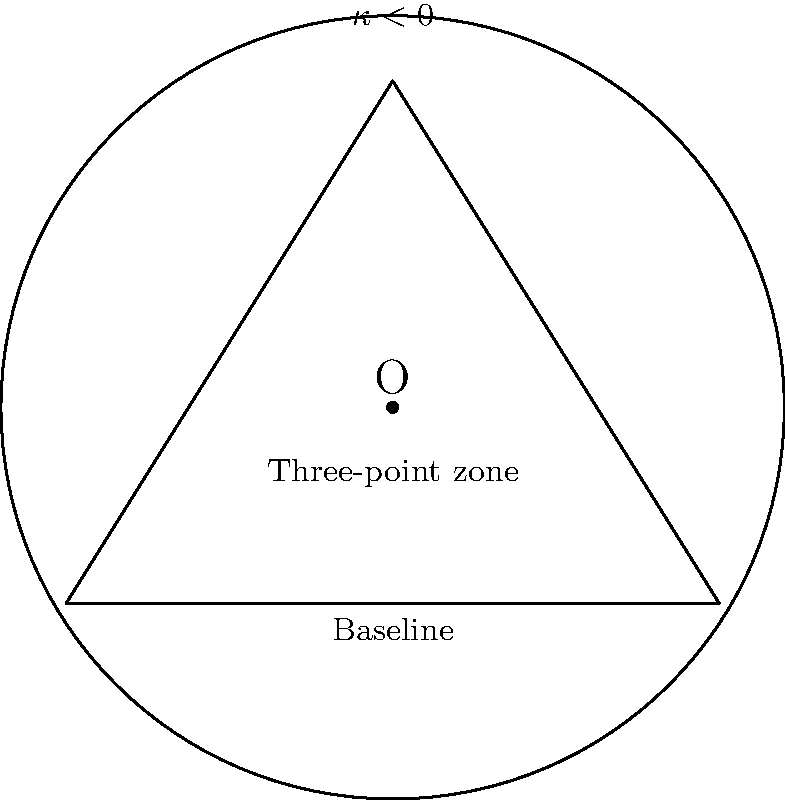As a dedicated Oregon Ducks basketball fan, you're analyzing the court's geometry. Imagine the three-point zone on a basketball court with constant negative curvature $\kappa < 0$. If the baseline length is $l$ and the distance from the baseline to the top of the three-point arc is $h$, express the area $A$ of the three-point zone in terms of $l$, $h$, and $\kappa$. Let's approach this step-by-step:

1) In hyperbolic geometry (constant negative curvature), we use the Poincaré disk model.

2) The area formula for a hyperbolic triangle with angles $\alpha$, $\beta$, and $\gamma$ is:

   $$A = \frac{\pi - (\alpha + \beta + \gamma)}{|\kappa|}$$

3) The three-point zone can be approximated as a hyperbolic triangle.

4) In a hyperbolic triangle, the sum of angles is less than $\pi$. Let's denote this sum as $S$:

   $$S = \alpha + \beta + \gamma < \pi$$

5) The area of the three-point zone is then:

   $$A = \frac{\pi - S}{|\kappa|}$$

6) To relate this to $l$ and $h$, we can use the hyperbolic Pythagorean theorem:

   $$\cosh(\sqrt{|\kappa|}c) = \cosh(\sqrt{|\kappa|}a)\cosh(\sqrt{|\kappa|}b)$$

   Where $c$ is the hypotenuse, and $a$ and $b$ are the other sides.

7) In our case, $a = l/2$, $b = h$, and $c$ is the radius of the three-point arc. Let's call this $r$.

8) Substituting:

   $$\cosh(\sqrt{|\kappa|}r) = \cosh(\sqrt{|\kappa|}l/2)\cosh(\sqrt{|\kappa|}h)$$

9) The angles of the triangle can be found using hyperbolic trigonometry, but this requires solving transcendental equations.

10) Therefore, the final area will be in the form:

    $$A = \frac{\pi - S(l,h,\kappa)}{|\kappa|}$$

    Where $S(l,h,\kappa)$ is a function of $l$, $h$, and $\kappa$ that represents the sum of the angles.
Answer: $A = \frac{\pi - S(l,h,\kappa)}{|\kappa|}$ 